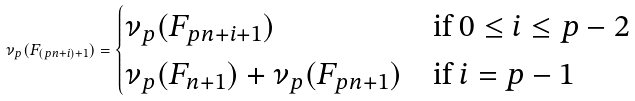Convert formula to latex. <formula><loc_0><loc_0><loc_500><loc_500>\nu _ { p } ( F _ { ( p n + i ) + 1 } ) = \begin{cases} \nu _ { p } ( F _ { p n + i + 1 } ) & \text {if $0 \leq i \leq p-2$} \\ \nu _ { p } ( F _ { n + 1 } ) + \nu _ { p } ( F _ { p n + 1 } ) & \text {if $i = p-1$} \end{cases}</formula> 